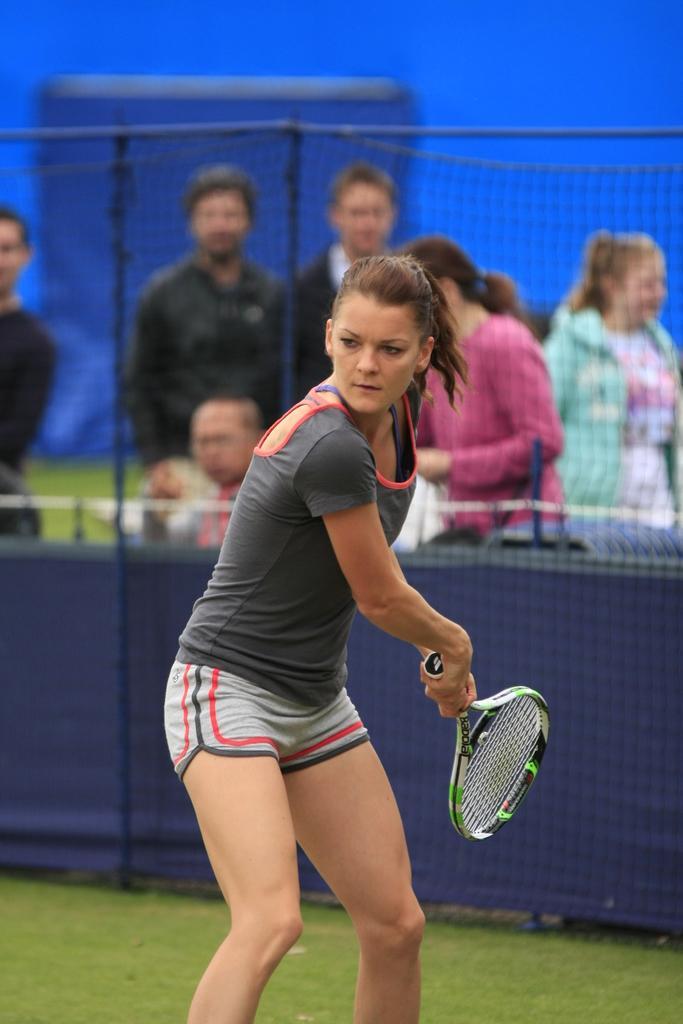How would you summarize this image in a sentence or two? A woman standing and holding tennis racket in her hands,behind her there are few people and a fence. 